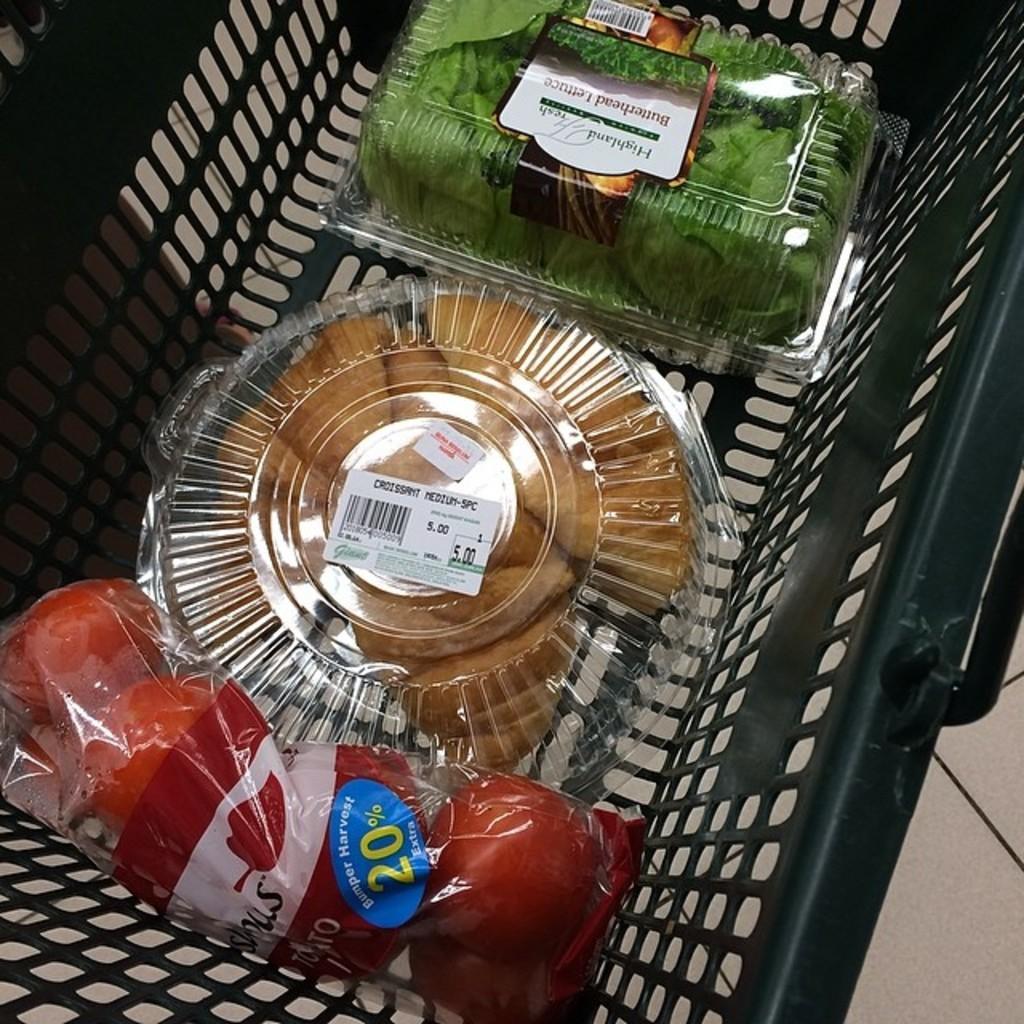Could you give a brief overview of what you see in this image? In the picture we can see a basket in it, we can see two plastic boxes with some food items in it and beside it, we can see some tomatoes are covered with polythene cover with a label for it. 